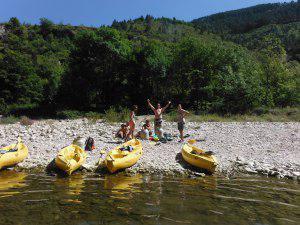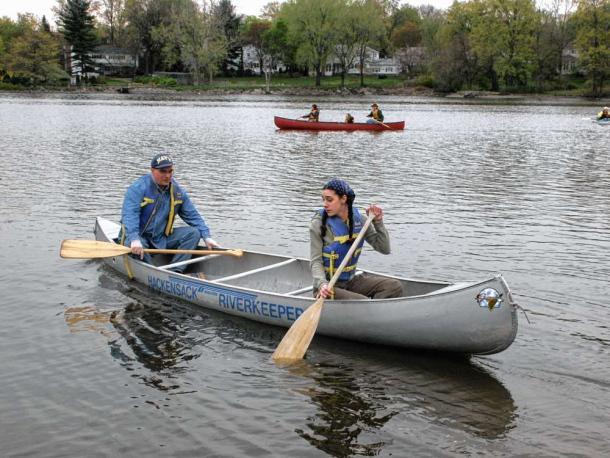The first image is the image on the left, the second image is the image on the right. Examine the images to the left and right. Is the description "At least three yellow kayaks are arranged in a row in one of the images." accurate? Answer yes or no. Yes. The first image is the image on the left, the second image is the image on the right. For the images displayed, is the sentence "rows of yellow canoes line the beach" factually correct? Answer yes or no. Yes. 